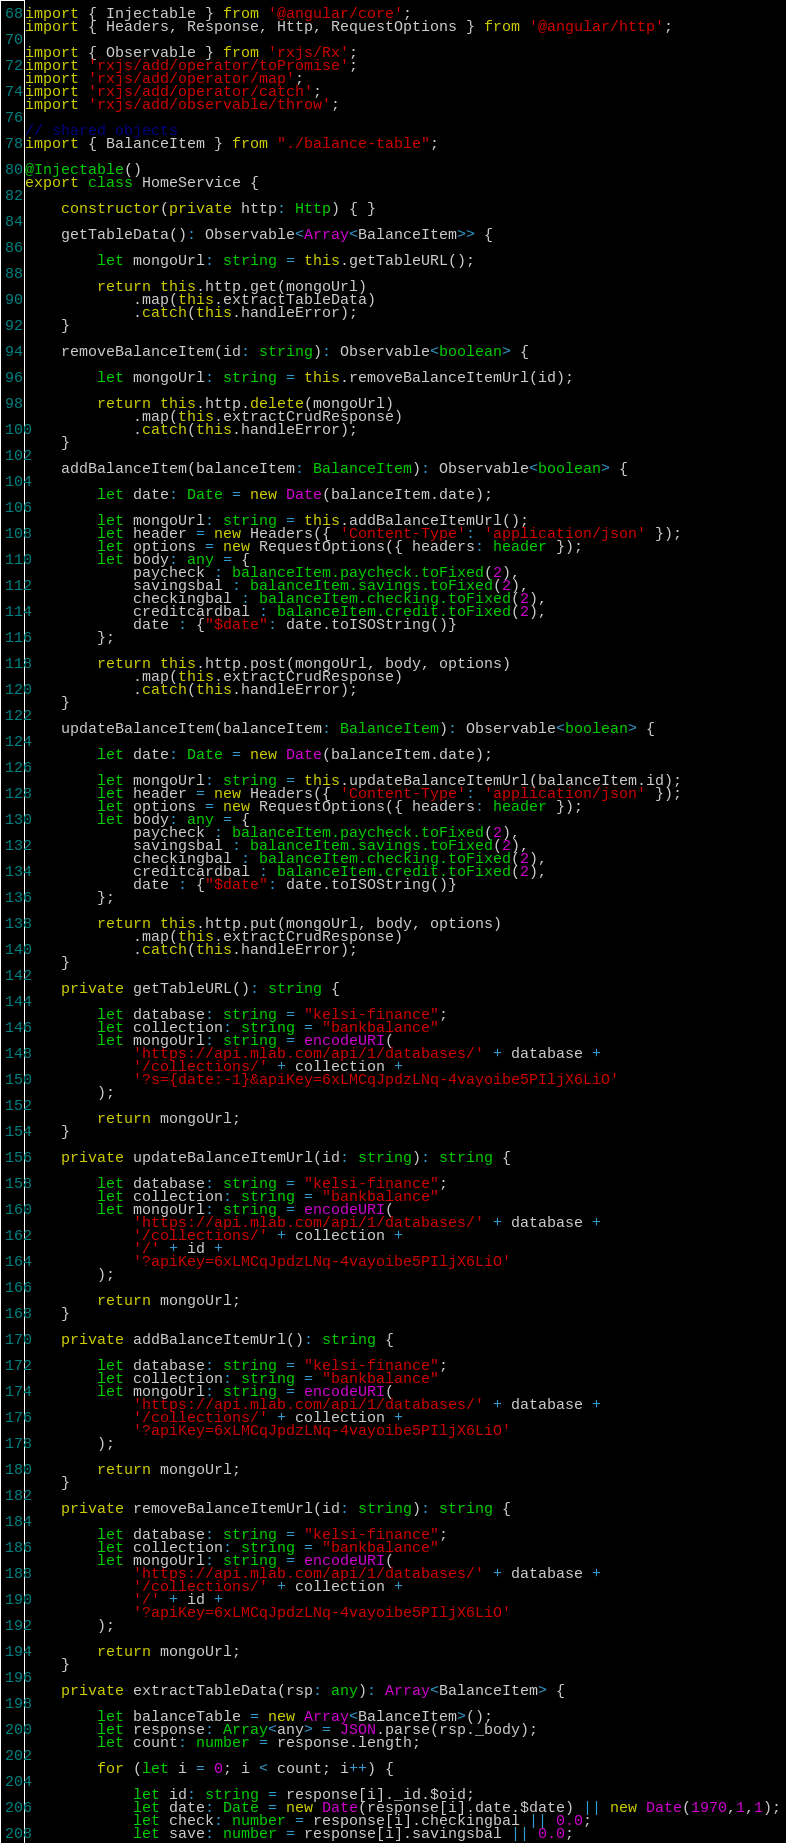<code> <loc_0><loc_0><loc_500><loc_500><_TypeScript_>import { Injectable } from '@angular/core';
import { Headers, Response, Http, RequestOptions } from '@angular/http';

import { Observable } from 'rxjs/Rx';
import 'rxjs/add/operator/toPromise';
import 'rxjs/add/operator/map';
import 'rxjs/add/operator/catch';
import 'rxjs/add/observable/throw';

// shared objects
import { BalanceItem } from "./balance-table";

@Injectable()
export class HomeService {

    constructor(private http: Http) { }

    getTableData(): Observable<Array<BalanceItem>> {

        let mongoUrl: string = this.getTableURL();

        return this.http.get(mongoUrl)
            .map(this.extractTableData)
            .catch(this.handleError);
    }

    removeBalanceItem(id: string): Observable<boolean> {

        let mongoUrl: string = this.removeBalanceItemUrl(id);
        
        return this.http.delete(mongoUrl)
            .map(this.extractCrudResponse)
            .catch(this.handleError);
    }

    addBalanceItem(balanceItem: BalanceItem): Observable<boolean> {

        let date: Date = new Date(balanceItem.date);

        let mongoUrl: string = this.addBalanceItemUrl();
        let header = new Headers({ 'Content-Type': 'application/json' });
        let options = new RequestOptions({ headers: header });
        let body: any = {
            paycheck : balanceItem.paycheck.toFixed(2),
            savingsbal : balanceItem.savings.toFixed(2),
            checkingbal : balanceItem.checking.toFixed(2),
            creditcardbal : balanceItem.credit.toFixed(2),
            date : {"$date": date.toISOString()}
        };
        
        return this.http.post(mongoUrl, body, options)
            .map(this.extractCrudResponse)
            .catch(this.handleError);
    }

    updateBalanceItem(balanceItem: BalanceItem): Observable<boolean> {

        let date: Date = new Date(balanceItem.date);
        
        let mongoUrl: string = this.updateBalanceItemUrl(balanceItem.id);
        let header = new Headers({ 'Content-Type': 'application/json' });
        let options = new RequestOptions({ headers: header });
        let body: any = {
            paycheck : balanceItem.paycheck.toFixed(2),
            savingsbal : balanceItem.savings.toFixed(2),
            checkingbal : balanceItem.checking.toFixed(2),
            creditcardbal : balanceItem.credit.toFixed(2),
            date : {"$date": date.toISOString()}
        };
        
        return this.http.put(mongoUrl, body, options)
            .map(this.extractCrudResponse)
            .catch(this.handleError);
    }

    private getTableURL(): string {

        let database: string = "kelsi-finance";
        let collection: string = "bankbalance"
        let mongoUrl: string = encodeURI(
            'https://api.mlab.com/api/1/databases/' + database +
            '/collections/' + collection +
            '?s={date:-1}&apiKey=6xLMCqJpdzLNq-4vayoibe5PIljX6LiO'
        );

        return mongoUrl;
    }

    private updateBalanceItemUrl(id: string): string {

        let database: string = "kelsi-finance";
        let collection: string = "bankbalance"
        let mongoUrl: string = encodeURI(
            'https://api.mlab.com/api/1/databases/' + database +
            '/collections/' + collection +
            '/' + id +
            '?apiKey=6xLMCqJpdzLNq-4vayoibe5PIljX6LiO'
        );
        
        return mongoUrl;
    }

    private addBalanceItemUrl(): string {

        let database: string = "kelsi-finance";
        let collection: string = "bankbalance"
        let mongoUrl: string = encodeURI(
            'https://api.mlab.com/api/1/databases/' + database +
            '/collections/' + collection +
            '?apiKey=6xLMCqJpdzLNq-4vayoibe5PIljX6LiO'
        );

        return mongoUrl;
    }

    private removeBalanceItemUrl(id: string): string {

        let database: string = "kelsi-finance";
        let collection: string = "bankbalance"
        let mongoUrl: string = encodeURI(
            'https://api.mlab.com/api/1/databases/' + database +
            '/collections/' + collection +
            '/' + id +
            '?apiKey=6xLMCqJpdzLNq-4vayoibe5PIljX6LiO'
        );

        return mongoUrl;
    }

    private extractTableData(rsp: any): Array<BalanceItem> {

        let balanceTable = new Array<BalanceItem>();
        let response: Array<any> = JSON.parse(rsp._body);
        let count: number = response.length;
        
        for (let i = 0; i < count; i++) {

            let id: string = response[i]._id.$oid;
            let date: Date = new Date(response[i].date.$date) || new Date(1970,1,1);
            let check: number = response[i].checkingbal || 0.0;
            let save: number = response[i].savingsbal || 0.0;</code> 